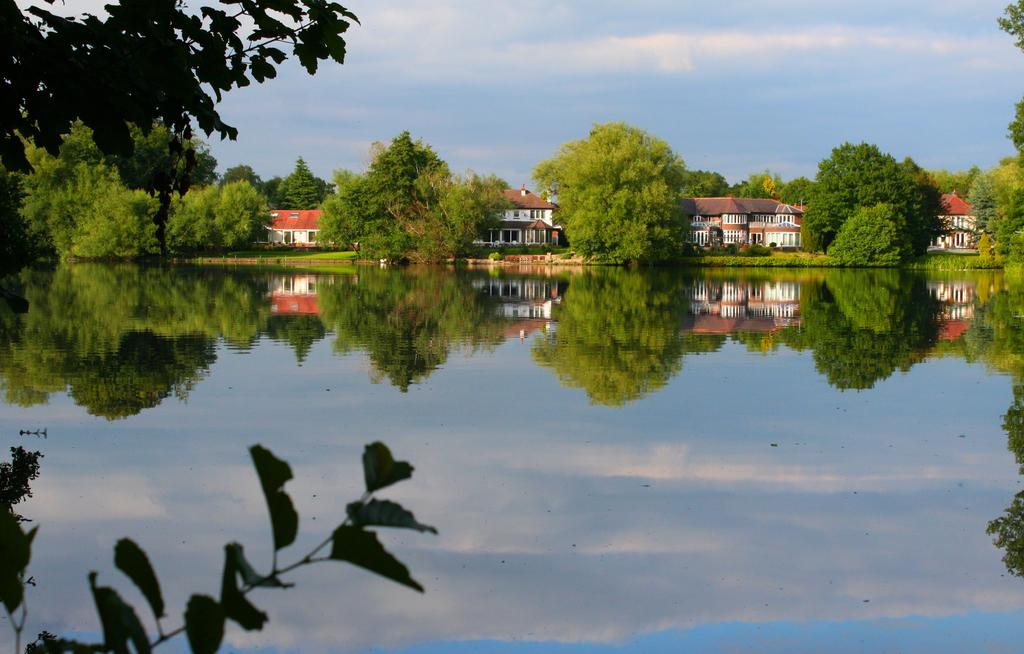What is visible in the image that is not a solid structure? Water is visible in the image. What type of natural vegetation can be seen in the image? There are trees in the image. What type of man-made structures are present in the image? There are buildings in the image. What is visible in the background of the image? The sky is visible in the image. What can be seen in the sky in the image? Clouds are present in the sky. Can you describe the level of pain experienced by the ants in the image? There are no ants present in the image, so it is not possible to describe their level of pain. What type of amusement can be seen in the image? There is no amusement park or any amusement-related objects present in the image. 